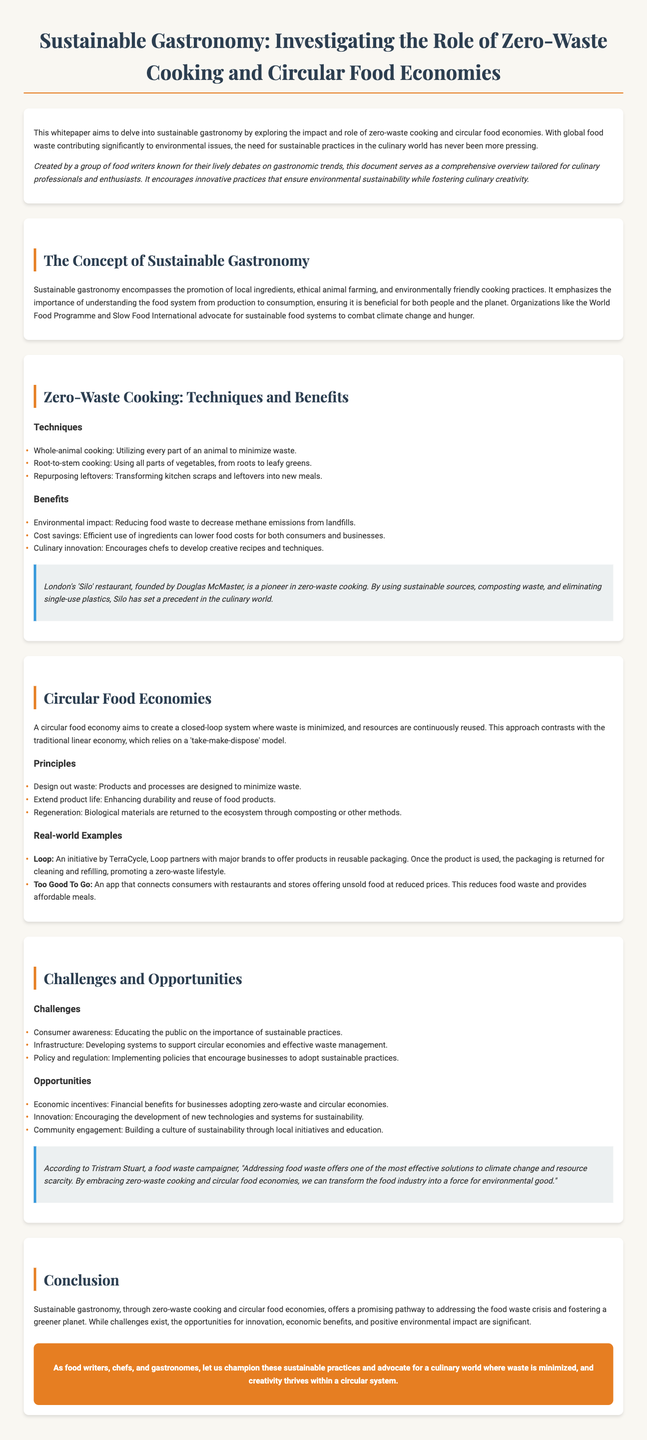What is the title of the whitepaper? The title of the whitepaper is displayed prominently at the top of the document.
Answer: Sustainable Gastronomy: Investigating the Role of Zero-Waste Cooking and Circular Food Economies Who is the founder of the 'Silo' restaurant? The whitepaper mentions Douglas McMaster as the founder of the 'Silo' restaurant.
Answer: Douglas McMaster What is one technique associated with zero-waste cooking? The document lists techniques used in zero-waste cooking under the respective section.
Answer: Whole-animal cooking What does a circular food economy aim to create? The document explains the aim of a circular food economy in the respective section.
Answer: Closed-loop system Which organization advocates for sustainable food systems? The document mentions organizations supporting sustainable practices.
Answer: World Food Programme What challenge related to sustainable practices is highlighted? The document discusses various challenges in the section on challenges and opportunities.
Answer: Consumer awareness What is a real-world example of a circular food economy initiative? The document provides examples of initiatives related to circular food economies.
Answer: Loop According to Tristram Stuart, what does addressing food waste offer? The expert opinion section cites Tristram Stuart's perspective on food waste.
Answer: Effective solutions to climate change What is the main theme of the conclusion? The conclusion summarizes the overall theme of sustainable practices in gastronomy.
Answer: Sustainable gastronomy 